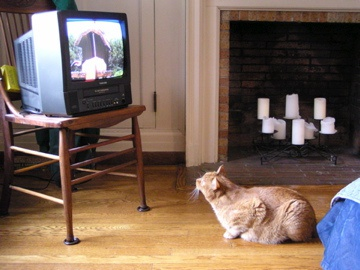Describe the objects in this image and their specific colors. I can see chair in black, maroon, brown, and gray tones, tv in black, white, and darkgray tones, and cat in black, tan, gray, and lightgray tones in this image. 